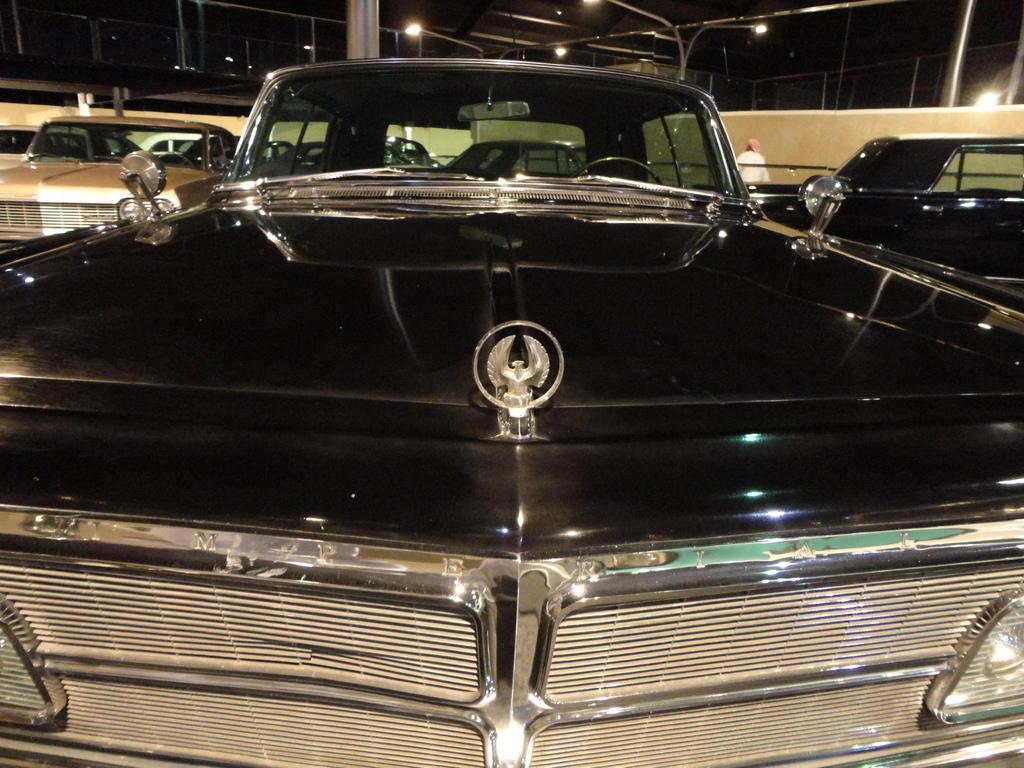How would you summarize this image in a sentence or two? In this picture we can see cars, wall and a person standing and in the background we can see the lights and rods. 